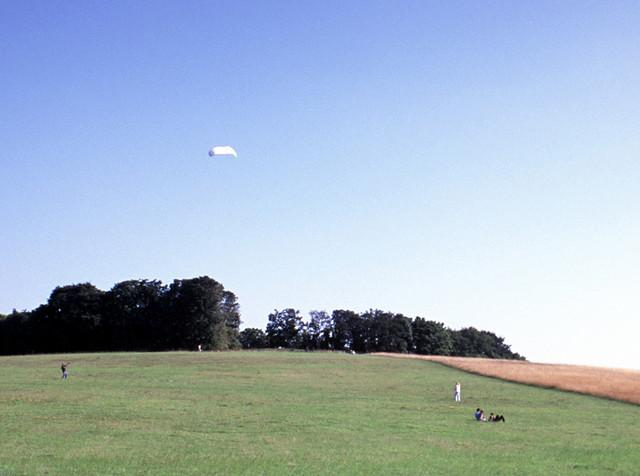What type of location is being visited? field 